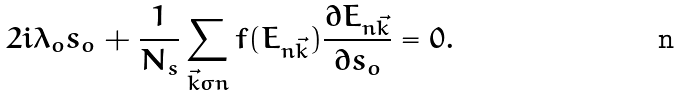Convert formula to latex. <formula><loc_0><loc_0><loc_500><loc_500>2 i \lambda _ { o } s _ { o } + \frac { 1 } { N _ { s } } \sum _ { \vec { k } \sigma n } f ( E _ { n \vec { k } } ) \frac { \partial E _ { n \vec { k } } } { \partial s _ { o } } = 0 .</formula> 